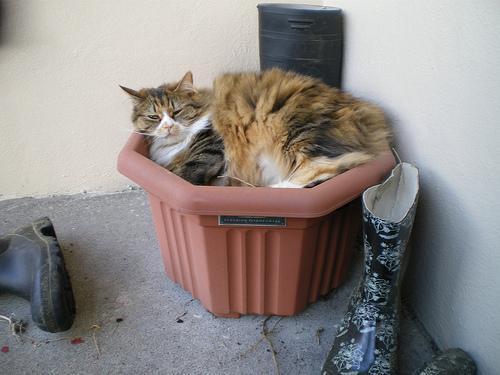How many cats are there?
Give a very brief answer. 1. 